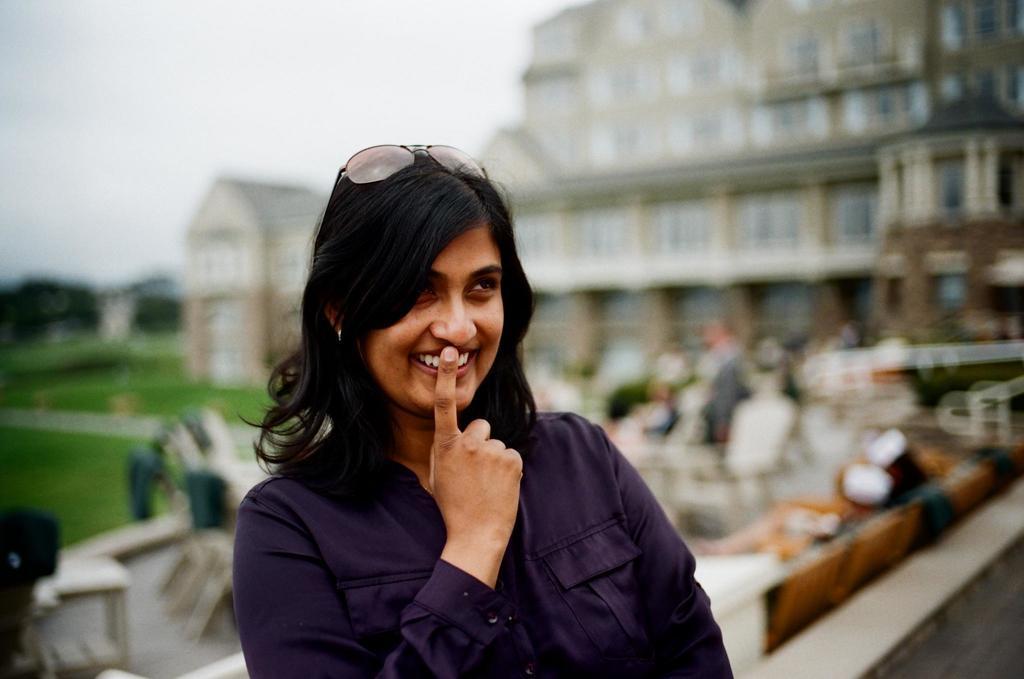Can you describe this image briefly? In this picture there is a lady in the center of the image and the background area of the image is blurred. 